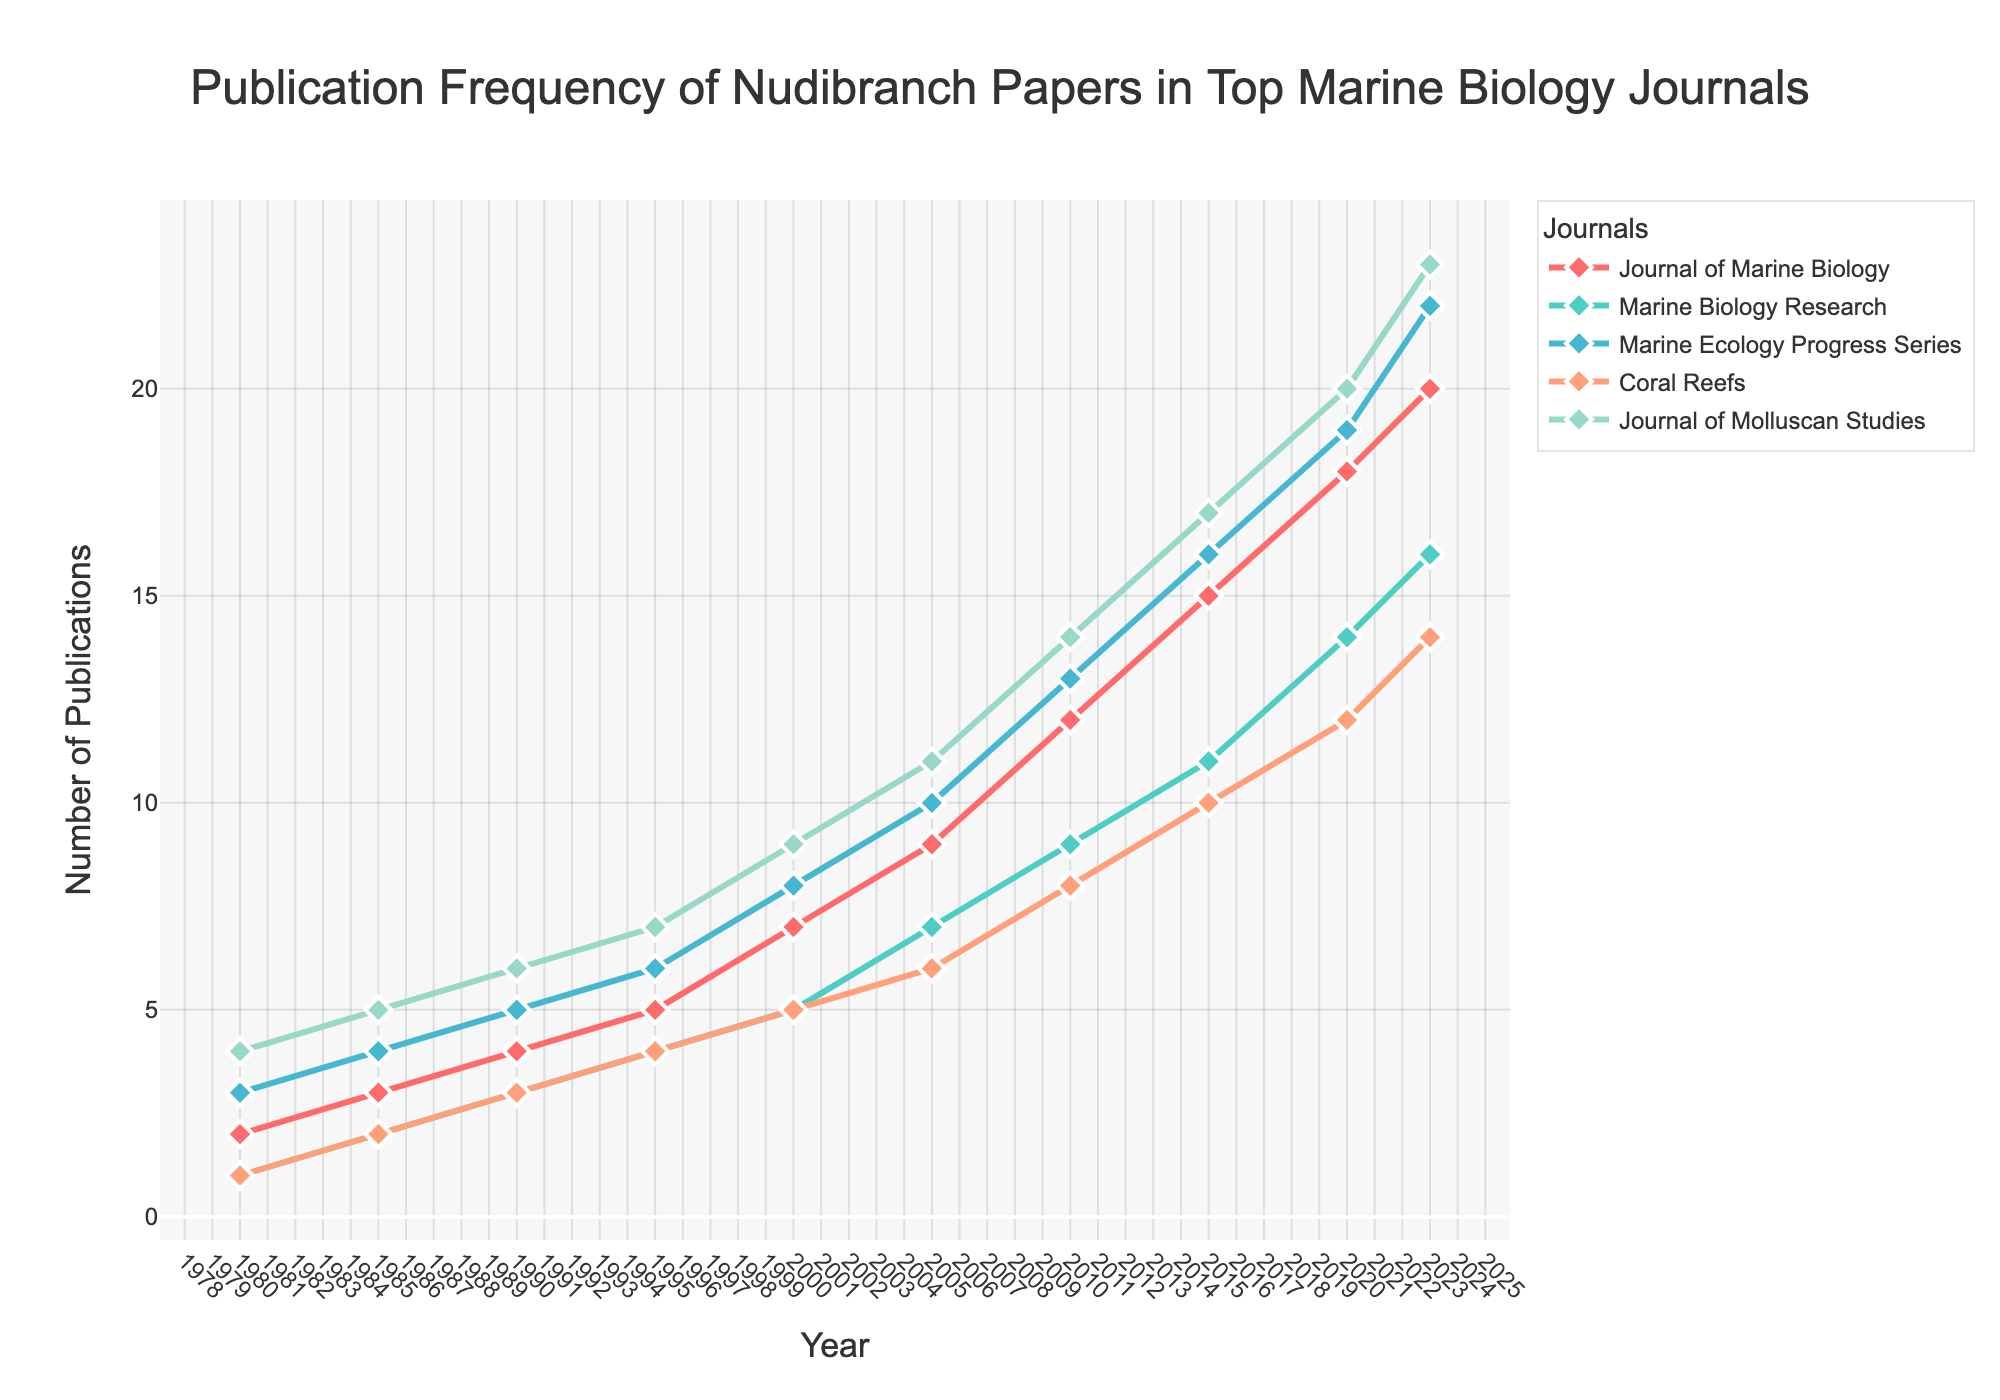What is the trend of publications in the Marine Ecology Progress Series journal from 1980 to 2023? The line for Marine Ecology Progress Series shows a consistent increase from 1980 to 2023, with the number of publications rising from 3 to 22.
Answer: Consistent increase Which journal had the highest number of publications in 2023? By comparing the endpoints of all lines, Journal of Molluscan Studies shows the highest number of publications in 2023 with 23 papers.
Answer: Journal of Molluscan Studies In what year did the Journal of Marine Biology and Marine Biology Research have the same number of publications, and what was the number? The intersecting point of the lines for Journal of Marine Biology and Marine Biology Research is in the year 1995, where both had 5 publications.
Answer: 1995, 5 publications How many more publications did Coral Reefs have in 2023 compared to 1985? From the plot, Coral Reefs had 14 publications in 2023 and 2 in 1985. The difference is calculated as 14 - 2 = 12.
Answer: 12 Which journal showed the steepest increase in publications from 2005 to 2010? By comparing the slopes of the lines between 2005 and 2010, Marine Ecology Progress Series showed the steepest increase, rising from 10 to 13 publications.
Answer: Marine Ecology Progress Series In which year did the Journal of Molluscan Studies reach 20 publications? Observing the line for Journal of Molluscan Studies, it hits 20 publications in the year 2020.
Answer: 2020 By how much did the number of publications in Marine Biology Research increase from 1980 to 2023? Marine Biology Research had 1 publication in 1980 and 16 in 2023. The increase is computed as 16 - 1 = 15 publications.
Answer: 15 Which journal had the smallest change in publication frequency between 2010 and 2015? All lines show an increase between 2010 and 2015, but Coral Reefs saw the smallest change, increasing from 8 to 10, which is a change of 2 publications.
Answer: Coral Reefs What was the average number of publications in Journal of Marine Biology across all recorded years? Summing the publications (2+3+4+5+7+9+12+15+18+20) equals 95. Dividing this by 10 years gives an average of 95 / 10 = 9.5 publications.
Answer: 9.5 Which journal had the second-highest number of publications in 1990? In 1990, the journals had the following counts: Journal of Molluscan Studies (6), Marine Ecology Progress Series (5), Journal of Marine Biology (4), Marine Biology Research (3), and Coral Reefs (3). The second highest is Marine Ecology Progress Series with 5 publications.
Answer: Marine Ecology Progress Series 